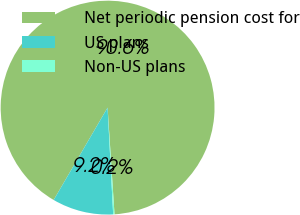<chart> <loc_0><loc_0><loc_500><loc_500><pie_chart><fcel>Net periodic pension cost for<fcel>US plans<fcel>Non-US plans<nl><fcel>90.56%<fcel>9.24%<fcel>0.2%<nl></chart> 